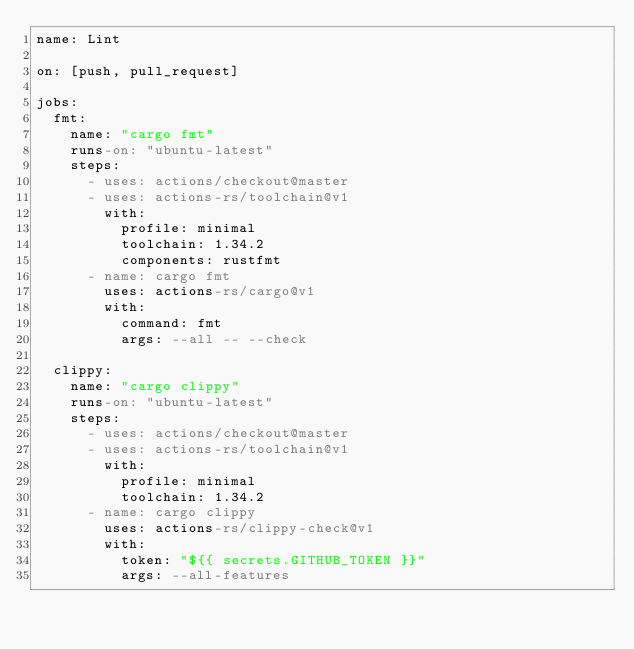<code> <loc_0><loc_0><loc_500><loc_500><_YAML_>name: Lint

on: [push, pull_request]

jobs:
  fmt:
    name: "cargo fmt"
    runs-on: "ubuntu-latest"
    steps:
      - uses: actions/checkout@master
      - uses: actions-rs/toolchain@v1
        with:
          profile: minimal
          toolchain: 1.34.2
          components: rustfmt
      - name: cargo fmt
        uses: actions-rs/cargo@v1
        with:
          command: fmt
          args: --all -- --check

  clippy:
    name: "cargo clippy"
    runs-on: "ubuntu-latest"
    steps:
      - uses: actions/checkout@master
      - uses: actions-rs/toolchain@v1
        with:
          profile: minimal
          toolchain: 1.34.2
      - name: cargo clippy
        uses: actions-rs/clippy-check@v1
        with:
          token: "${{ secrets.GITHUB_TOKEN }}"
          args: --all-features
</code> 